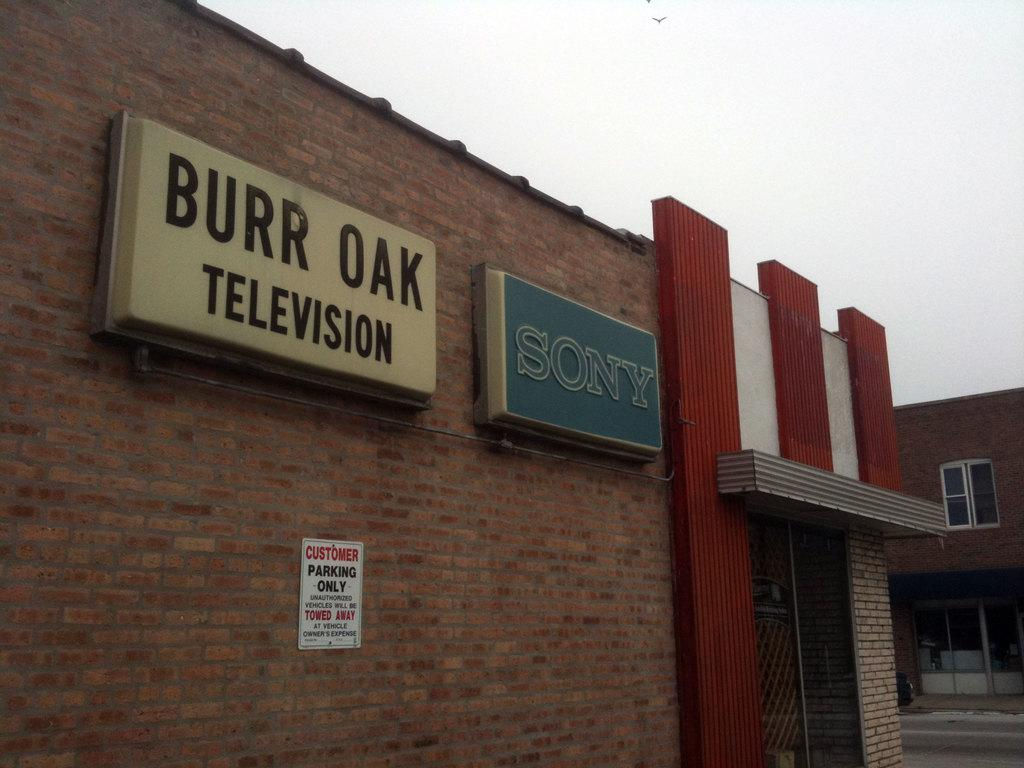What type of man-made structure can be seen in the image? There are buildings in the image. What is the primary mode of transportation visible in the image? There is a road in the image. Can you describe a specific feature of one of the buildings? There is a window in the image, which is a feature of one of the buildings. What is hanging on the wall in the image? There is a poster on a wall in the image. What can be seen in the background of the image? The sky is visible in the background of the image. Where is the beggar sitting in the image? There is no beggar present in the image. What type of furniture is visible in the image? There is no furniture, such as a sofa, present in the image. 